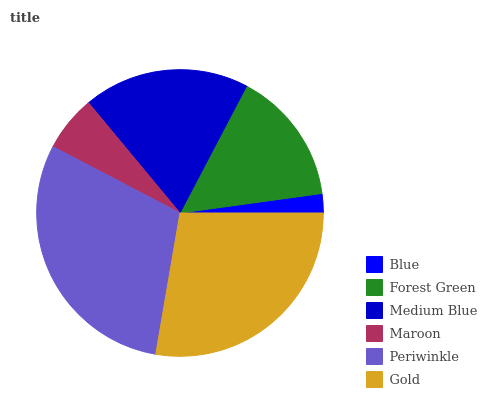Is Blue the minimum?
Answer yes or no. Yes. Is Periwinkle the maximum?
Answer yes or no. Yes. Is Forest Green the minimum?
Answer yes or no. No. Is Forest Green the maximum?
Answer yes or no. No. Is Forest Green greater than Blue?
Answer yes or no. Yes. Is Blue less than Forest Green?
Answer yes or no. Yes. Is Blue greater than Forest Green?
Answer yes or no. No. Is Forest Green less than Blue?
Answer yes or no. No. Is Medium Blue the high median?
Answer yes or no. Yes. Is Forest Green the low median?
Answer yes or no. Yes. Is Forest Green the high median?
Answer yes or no. No. Is Blue the low median?
Answer yes or no. No. 